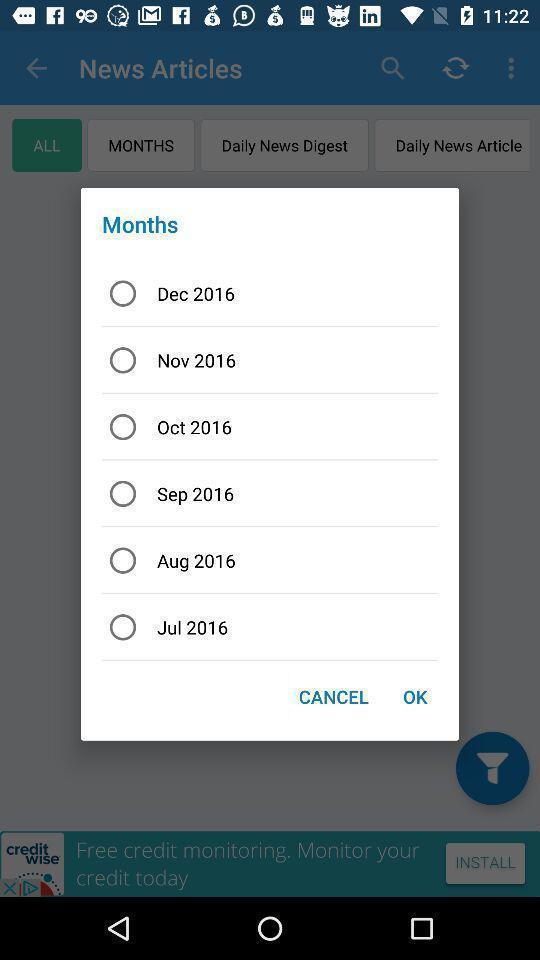Provide a textual representation of this image. Push-up displaying list of months. 